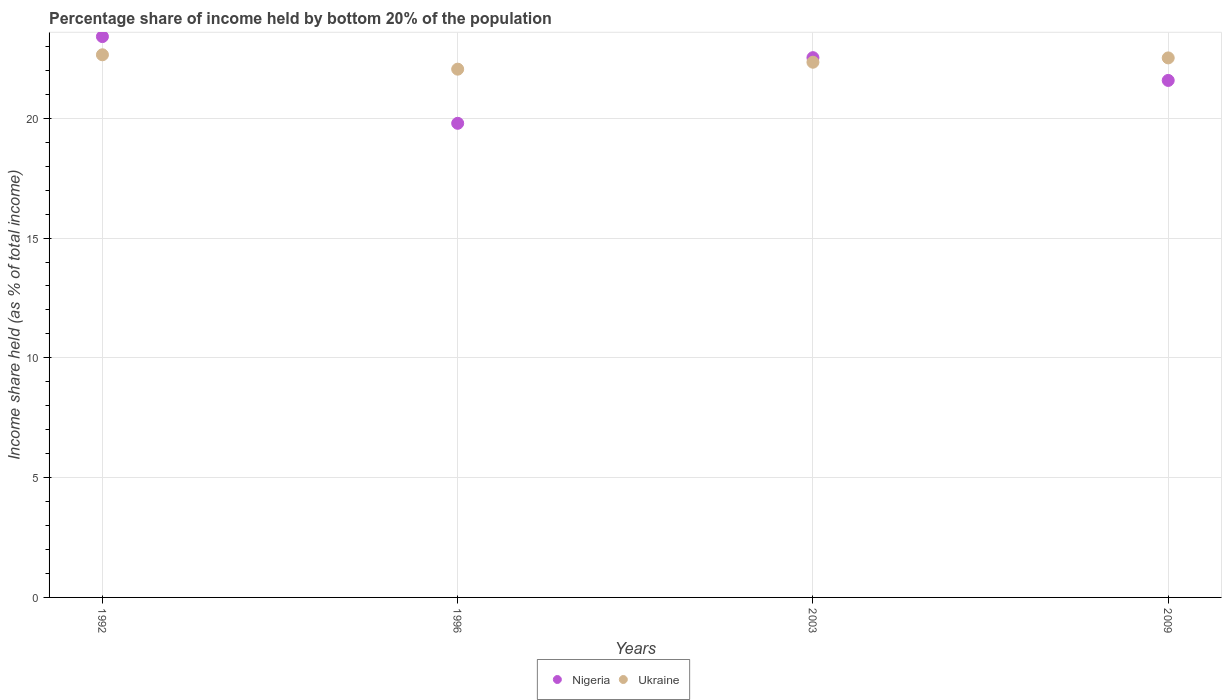How many different coloured dotlines are there?
Offer a terse response. 2. Is the number of dotlines equal to the number of legend labels?
Provide a short and direct response. Yes. What is the share of income held by bottom 20% of the population in Nigeria in 1992?
Give a very brief answer. 23.41. Across all years, what is the maximum share of income held by bottom 20% of the population in Ukraine?
Ensure brevity in your answer.  22.65. Across all years, what is the minimum share of income held by bottom 20% of the population in Ukraine?
Your answer should be compact. 22.05. In which year was the share of income held by bottom 20% of the population in Nigeria maximum?
Offer a very short reply. 1992. What is the total share of income held by bottom 20% of the population in Ukraine in the graph?
Your answer should be very brief. 89.56. What is the difference between the share of income held by bottom 20% of the population in Ukraine in 1992 and that in 2009?
Your response must be concise. 0.13. What is the difference between the share of income held by bottom 20% of the population in Ukraine in 1992 and the share of income held by bottom 20% of the population in Nigeria in 2003?
Your answer should be compact. 0.12. What is the average share of income held by bottom 20% of the population in Nigeria per year?
Provide a short and direct response. 21.83. In the year 1992, what is the difference between the share of income held by bottom 20% of the population in Ukraine and share of income held by bottom 20% of the population in Nigeria?
Keep it short and to the point. -0.76. In how many years, is the share of income held by bottom 20% of the population in Ukraine greater than 6 %?
Offer a terse response. 4. What is the ratio of the share of income held by bottom 20% of the population in Ukraine in 1992 to that in 1996?
Your answer should be compact. 1.03. Is the share of income held by bottom 20% of the population in Nigeria in 2003 less than that in 2009?
Keep it short and to the point. No. What is the difference between the highest and the second highest share of income held by bottom 20% of the population in Ukraine?
Give a very brief answer. 0.13. What is the difference between the highest and the lowest share of income held by bottom 20% of the population in Ukraine?
Provide a succinct answer. 0.6. Is the sum of the share of income held by bottom 20% of the population in Ukraine in 1996 and 2003 greater than the maximum share of income held by bottom 20% of the population in Nigeria across all years?
Your answer should be compact. Yes. Does the share of income held by bottom 20% of the population in Nigeria monotonically increase over the years?
Provide a succinct answer. No. How many dotlines are there?
Offer a very short reply. 2. What is the difference between two consecutive major ticks on the Y-axis?
Offer a terse response. 5. Where does the legend appear in the graph?
Make the answer very short. Bottom center. What is the title of the graph?
Provide a succinct answer. Percentage share of income held by bottom 20% of the population. Does "Middle East & North Africa (all income levels)" appear as one of the legend labels in the graph?
Give a very brief answer. No. What is the label or title of the X-axis?
Offer a very short reply. Years. What is the label or title of the Y-axis?
Offer a terse response. Income share held (as % of total income). What is the Income share held (as % of total income) of Nigeria in 1992?
Your answer should be very brief. 23.41. What is the Income share held (as % of total income) of Ukraine in 1992?
Offer a terse response. 22.65. What is the Income share held (as % of total income) in Nigeria in 1996?
Ensure brevity in your answer.  19.79. What is the Income share held (as % of total income) in Ukraine in 1996?
Offer a terse response. 22.05. What is the Income share held (as % of total income) in Nigeria in 2003?
Your response must be concise. 22.53. What is the Income share held (as % of total income) in Ukraine in 2003?
Make the answer very short. 22.34. What is the Income share held (as % of total income) of Nigeria in 2009?
Your answer should be compact. 21.58. What is the Income share held (as % of total income) in Ukraine in 2009?
Offer a terse response. 22.52. Across all years, what is the maximum Income share held (as % of total income) in Nigeria?
Give a very brief answer. 23.41. Across all years, what is the maximum Income share held (as % of total income) of Ukraine?
Provide a succinct answer. 22.65. Across all years, what is the minimum Income share held (as % of total income) of Nigeria?
Ensure brevity in your answer.  19.79. Across all years, what is the minimum Income share held (as % of total income) of Ukraine?
Offer a very short reply. 22.05. What is the total Income share held (as % of total income) in Nigeria in the graph?
Give a very brief answer. 87.31. What is the total Income share held (as % of total income) in Ukraine in the graph?
Offer a terse response. 89.56. What is the difference between the Income share held (as % of total income) in Nigeria in 1992 and that in 1996?
Give a very brief answer. 3.62. What is the difference between the Income share held (as % of total income) in Ukraine in 1992 and that in 2003?
Your answer should be very brief. 0.31. What is the difference between the Income share held (as % of total income) of Nigeria in 1992 and that in 2009?
Give a very brief answer. 1.83. What is the difference between the Income share held (as % of total income) in Ukraine in 1992 and that in 2009?
Ensure brevity in your answer.  0.13. What is the difference between the Income share held (as % of total income) in Nigeria in 1996 and that in 2003?
Keep it short and to the point. -2.74. What is the difference between the Income share held (as % of total income) of Ukraine in 1996 and that in 2003?
Make the answer very short. -0.29. What is the difference between the Income share held (as % of total income) of Nigeria in 1996 and that in 2009?
Your answer should be very brief. -1.79. What is the difference between the Income share held (as % of total income) of Ukraine in 1996 and that in 2009?
Offer a terse response. -0.47. What is the difference between the Income share held (as % of total income) in Ukraine in 2003 and that in 2009?
Give a very brief answer. -0.18. What is the difference between the Income share held (as % of total income) in Nigeria in 1992 and the Income share held (as % of total income) in Ukraine in 1996?
Keep it short and to the point. 1.36. What is the difference between the Income share held (as % of total income) of Nigeria in 1992 and the Income share held (as % of total income) of Ukraine in 2003?
Offer a very short reply. 1.07. What is the difference between the Income share held (as % of total income) of Nigeria in 1992 and the Income share held (as % of total income) of Ukraine in 2009?
Offer a very short reply. 0.89. What is the difference between the Income share held (as % of total income) of Nigeria in 1996 and the Income share held (as % of total income) of Ukraine in 2003?
Ensure brevity in your answer.  -2.55. What is the difference between the Income share held (as % of total income) of Nigeria in 1996 and the Income share held (as % of total income) of Ukraine in 2009?
Make the answer very short. -2.73. What is the difference between the Income share held (as % of total income) in Nigeria in 2003 and the Income share held (as % of total income) in Ukraine in 2009?
Give a very brief answer. 0.01. What is the average Income share held (as % of total income) of Nigeria per year?
Your answer should be very brief. 21.83. What is the average Income share held (as % of total income) in Ukraine per year?
Your answer should be very brief. 22.39. In the year 1992, what is the difference between the Income share held (as % of total income) in Nigeria and Income share held (as % of total income) in Ukraine?
Give a very brief answer. 0.76. In the year 1996, what is the difference between the Income share held (as % of total income) of Nigeria and Income share held (as % of total income) of Ukraine?
Make the answer very short. -2.26. In the year 2003, what is the difference between the Income share held (as % of total income) of Nigeria and Income share held (as % of total income) of Ukraine?
Provide a short and direct response. 0.19. In the year 2009, what is the difference between the Income share held (as % of total income) in Nigeria and Income share held (as % of total income) in Ukraine?
Make the answer very short. -0.94. What is the ratio of the Income share held (as % of total income) in Nigeria in 1992 to that in 1996?
Your answer should be compact. 1.18. What is the ratio of the Income share held (as % of total income) of Ukraine in 1992 to that in 1996?
Your response must be concise. 1.03. What is the ratio of the Income share held (as % of total income) of Nigeria in 1992 to that in 2003?
Your answer should be compact. 1.04. What is the ratio of the Income share held (as % of total income) of Ukraine in 1992 to that in 2003?
Your response must be concise. 1.01. What is the ratio of the Income share held (as % of total income) of Nigeria in 1992 to that in 2009?
Make the answer very short. 1.08. What is the ratio of the Income share held (as % of total income) of Ukraine in 1992 to that in 2009?
Provide a short and direct response. 1.01. What is the ratio of the Income share held (as % of total income) in Nigeria in 1996 to that in 2003?
Make the answer very short. 0.88. What is the ratio of the Income share held (as % of total income) in Nigeria in 1996 to that in 2009?
Give a very brief answer. 0.92. What is the ratio of the Income share held (as % of total income) in Ukraine in 1996 to that in 2009?
Your answer should be compact. 0.98. What is the ratio of the Income share held (as % of total income) of Nigeria in 2003 to that in 2009?
Give a very brief answer. 1.04. What is the difference between the highest and the second highest Income share held (as % of total income) of Nigeria?
Offer a very short reply. 0.88. What is the difference between the highest and the second highest Income share held (as % of total income) of Ukraine?
Provide a succinct answer. 0.13. What is the difference between the highest and the lowest Income share held (as % of total income) in Nigeria?
Your answer should be compact. 3.62. 